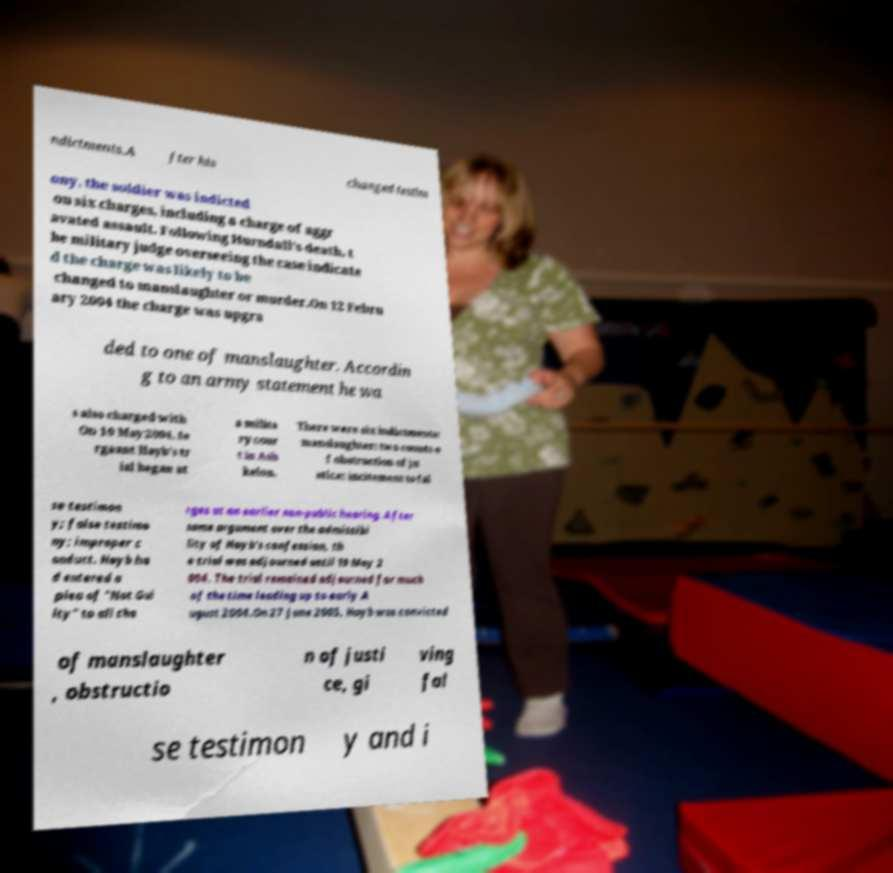I need the written content from this picture converted into text. Can you do that? ndictments.A fter his changed testim ony, the soldier was indicted on six charges, including a charge of aggr avated assault. Following Hurndall's death, t he military judge overseeing the case indicate d the charge was likely to be changed to manslaughter or murder.On 12 Febru ary 2004 the charge was upgra ded to one of manslaughter. Accordin g to an army statement he wa s also charged with On 10 May 2004, Se rgeant Hayb's tr ial began at a milita ry cour t in Ash kelon. There were six indictments: manslaughter; two counts o f obstruction of ju stice; incitement to fal se testimon y; false testimo ny; improper c onduct. Hayb ha d entered a plea of "Not Gui lty" to all cha rges at an earlier non-public hearing. After some argument over the admissibi lity of Hayb's confession, th e trial was adjourned until 19 May 2 004. The trial remained adjourned for much of the time leading up to early A ugust 2004.On 27 June 2005, Hayb was convicted of manslaughter , obstructio n of justi ce, gi ving fal se testimon y and i 